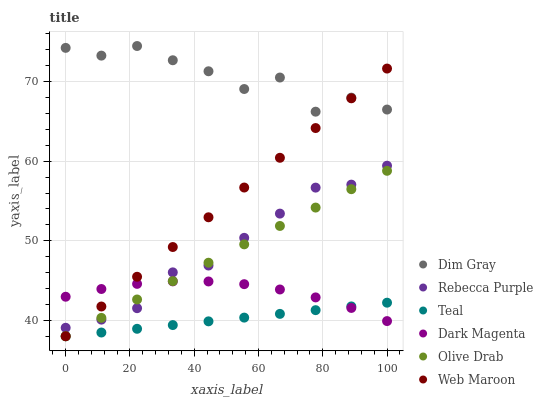Does Teal have the minimum area under the curve?
Answer yes or no. Yes. Does Dim Gray have the maximum area under the curve?
Answer yes or no. Yes. Does Dark Magenta have the minimum area under the curve?
Answer yes or no. No. Does Dark Magenta have the maximum area under the curve?
Answer yes or no. No. Is Teal the smoothest?
Answer yes or no. Yes. Is Dim Gray the roughest?
Answer yes or no. Yes. Is Dark Magenta the smoothest?
Answer yes or no. No. Is Dark Magenta the roughest?
Answer yes or no. No. Does Web Maroon have the lowest value?
Answer yes or no. Yes. Does Dark Magenta have the lowest value?
Answer yes or no. No. Does Dim Gray have the highest value?
Answer yes or no. Yes. Does Dark Magenta have the highest value?
Answer yes or no. No. Is Teal less than Rebecca Purple?
Answer yes or no. Yes. Is Dim Gray greater than Dark Magenta?
Answer yes or no. Yes. Does Olive Drab intersect Dark Magenta?
Answer yes or no. Yes. Is Olive Drab less than Dark Magenta?
Answer yes or no. No. Is Olive Drab greater than Dark Magenta?
Answer yes or no. No. Does Teal intersect Rebecca Purple?
Answer yes or no. No. 